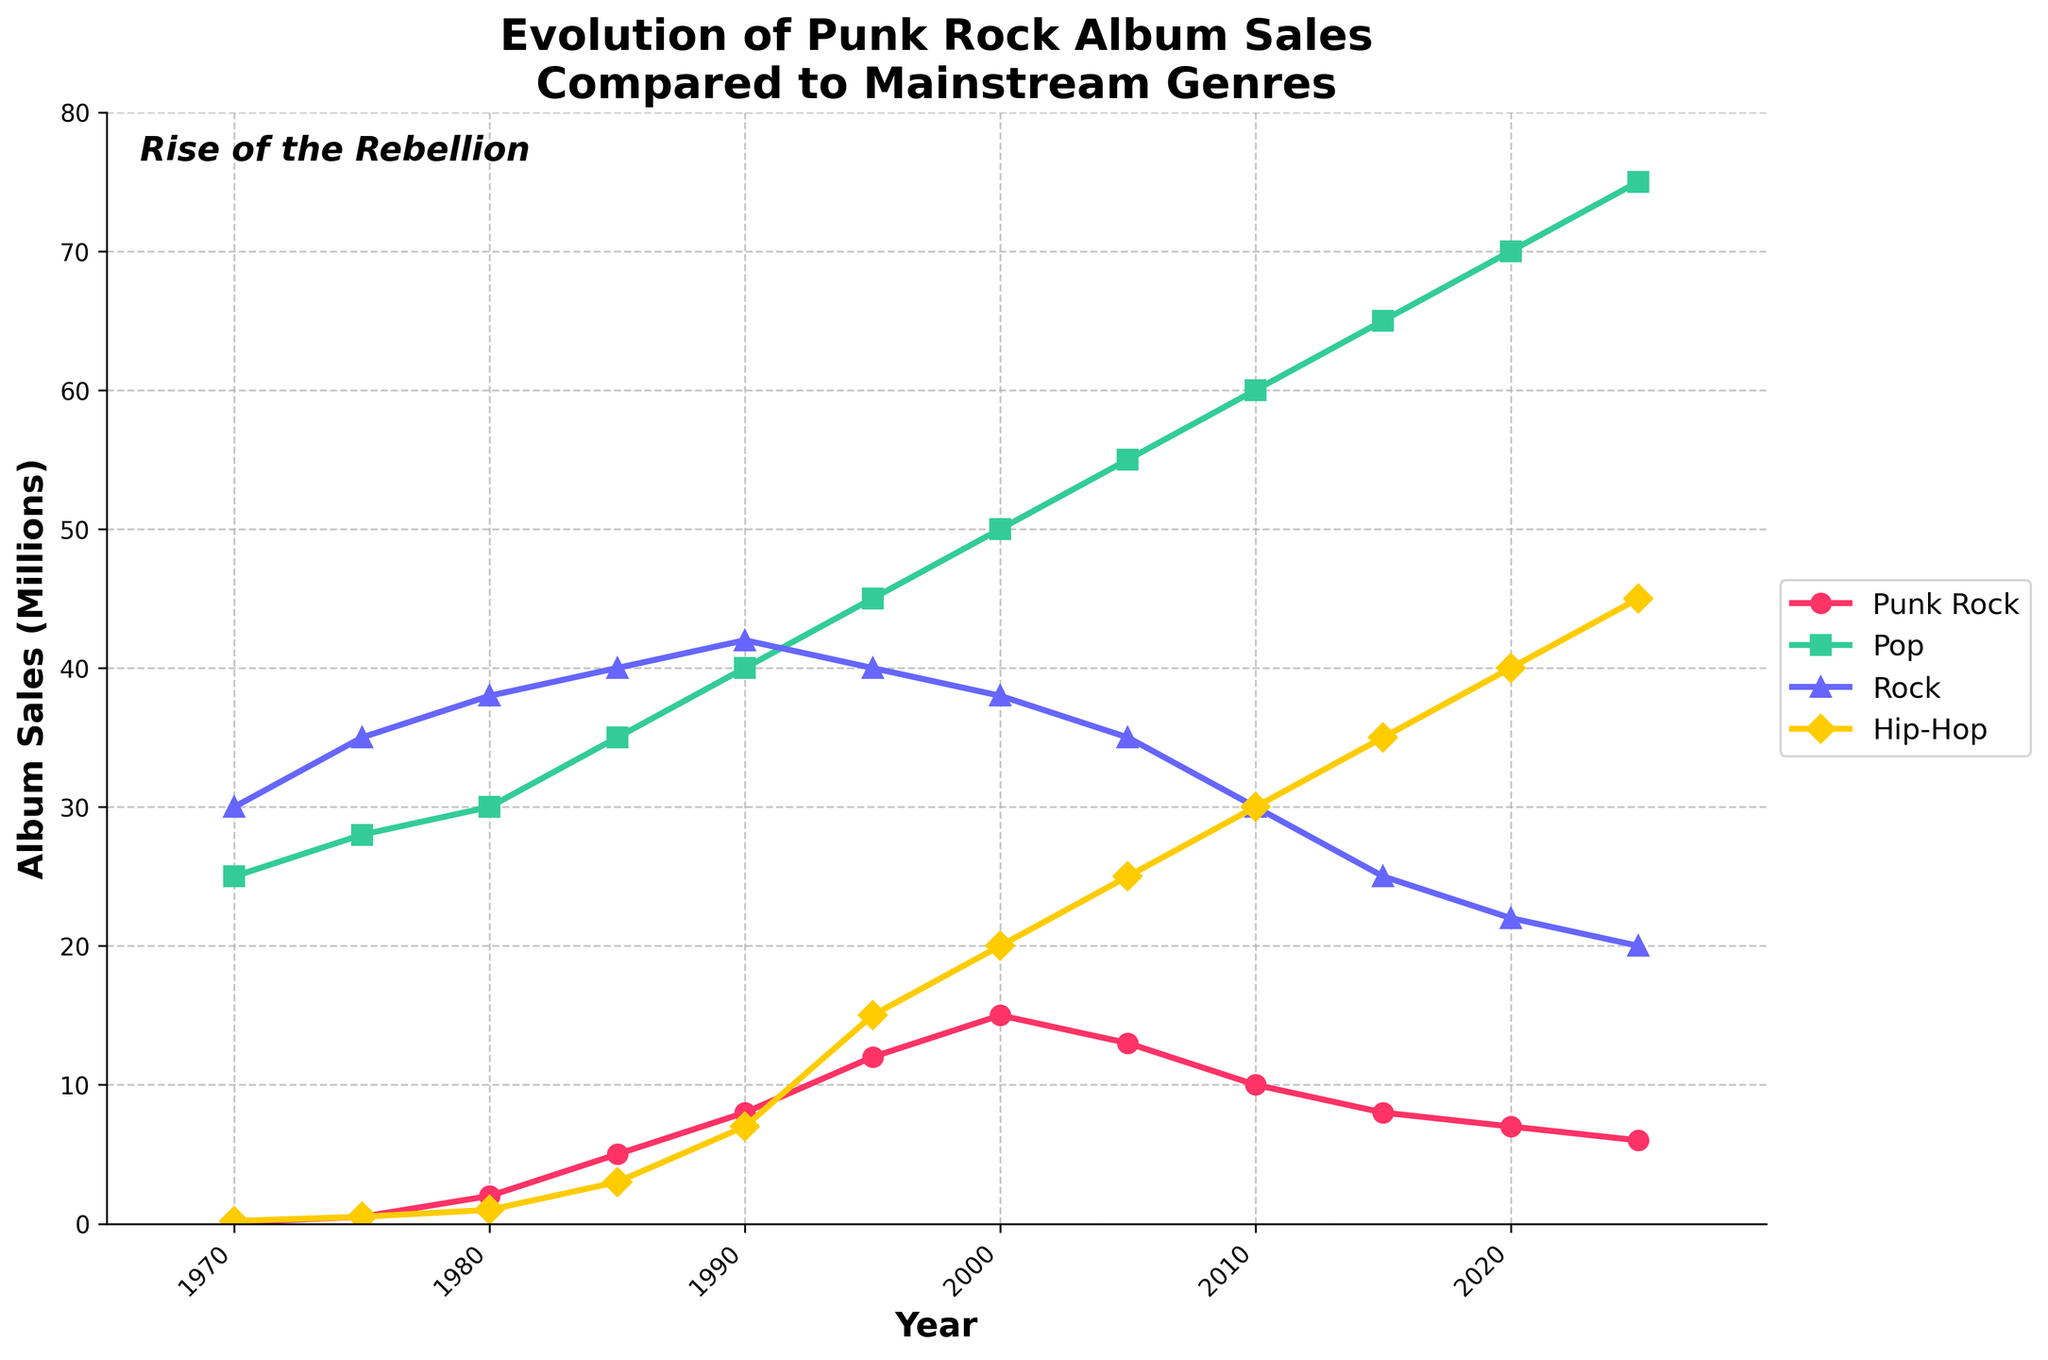What was the trend in Punk Rock album sales from 1970 to 2025? Punk Rock album sales increased steadily from 0.1 million in 1970 to 15 million in 2000, but then started declining to 6 million by 2025.
Answer: Increasing until 2000, then decreasing Which genre had the highest album sales in 2025? In 2025, the Pop genre had the highest album sales, reaching 75 million albums sold.
Answer: Pop By how much did Hip-Hop album sales increase from 1970 to 2025? In 1970, Hip-Hop album sales were 0.2 million. In 2025, they were 45 million. The difference is 45 - 0.2 = 44.8 million.
Answer: 44.8 million How does the change in Rock album sales from 1970 to 2025 compare to Punk Rock? Rock album sales slightly decreased from 30 million in 1970 to 20 million in 2025, whereas Punk Rock sales increased initially but then declined, starting from 0.1 million in 1970 to 6 million in 2025.
Answer: Rock decreased by 10 million, Punk Rock increased by 5.9 million What is the visual pattern of the Hip-Hop line on the graph? The Hip-Hop line, marked in bright yellow, shows a steady and significant increase, rising from 0.2 million in 1970 to 45 million in 2025.
Answer: Steady and significant increase Which genres experienced a decline in album sales after 2000? Both Punk Rock and Rock experienced a decline in album sales after 2000, with Punk Rock dropping from 15 million to 6 million and Rock dropping from 38 million to 20 million.
Answer: Punk Rock and Rock Compare the album sales of Punk Rock and Pop in the year 2000. In 2000, Punk Rock album sales were 15 million, whereas Pop album sales were 50 million. Pop sales were much higher than Punk Rock.
Answer: Pop > Punk Rock What was the biggest percentage increase in Punk Rock sales from one decade to the next? The biggest percentage increase in Punk Rock sales was between 1980 and 1985, going from 2 million to 5 million, an increase of (5-2)/2 = 1.5 or 150%.
Answer: 150% How did Punk Rock album sales perform relative to other genres in 1995? In 1995, Punk Rock had 12 million albums sold, lower than both Pop and Rock, which had 45 million and 40 million respectively, but higher than Hip-Hop, which had 15 million.
Answer: Lower than Pop and Rock, higher than Hip-Hop In which year did Pop album sales start consistently surpassing Rock album sales? Pop album sales started consistently surpassing Rock album sales in the 1990s and continued to do so through 2025.
Answer: In the 1990s 